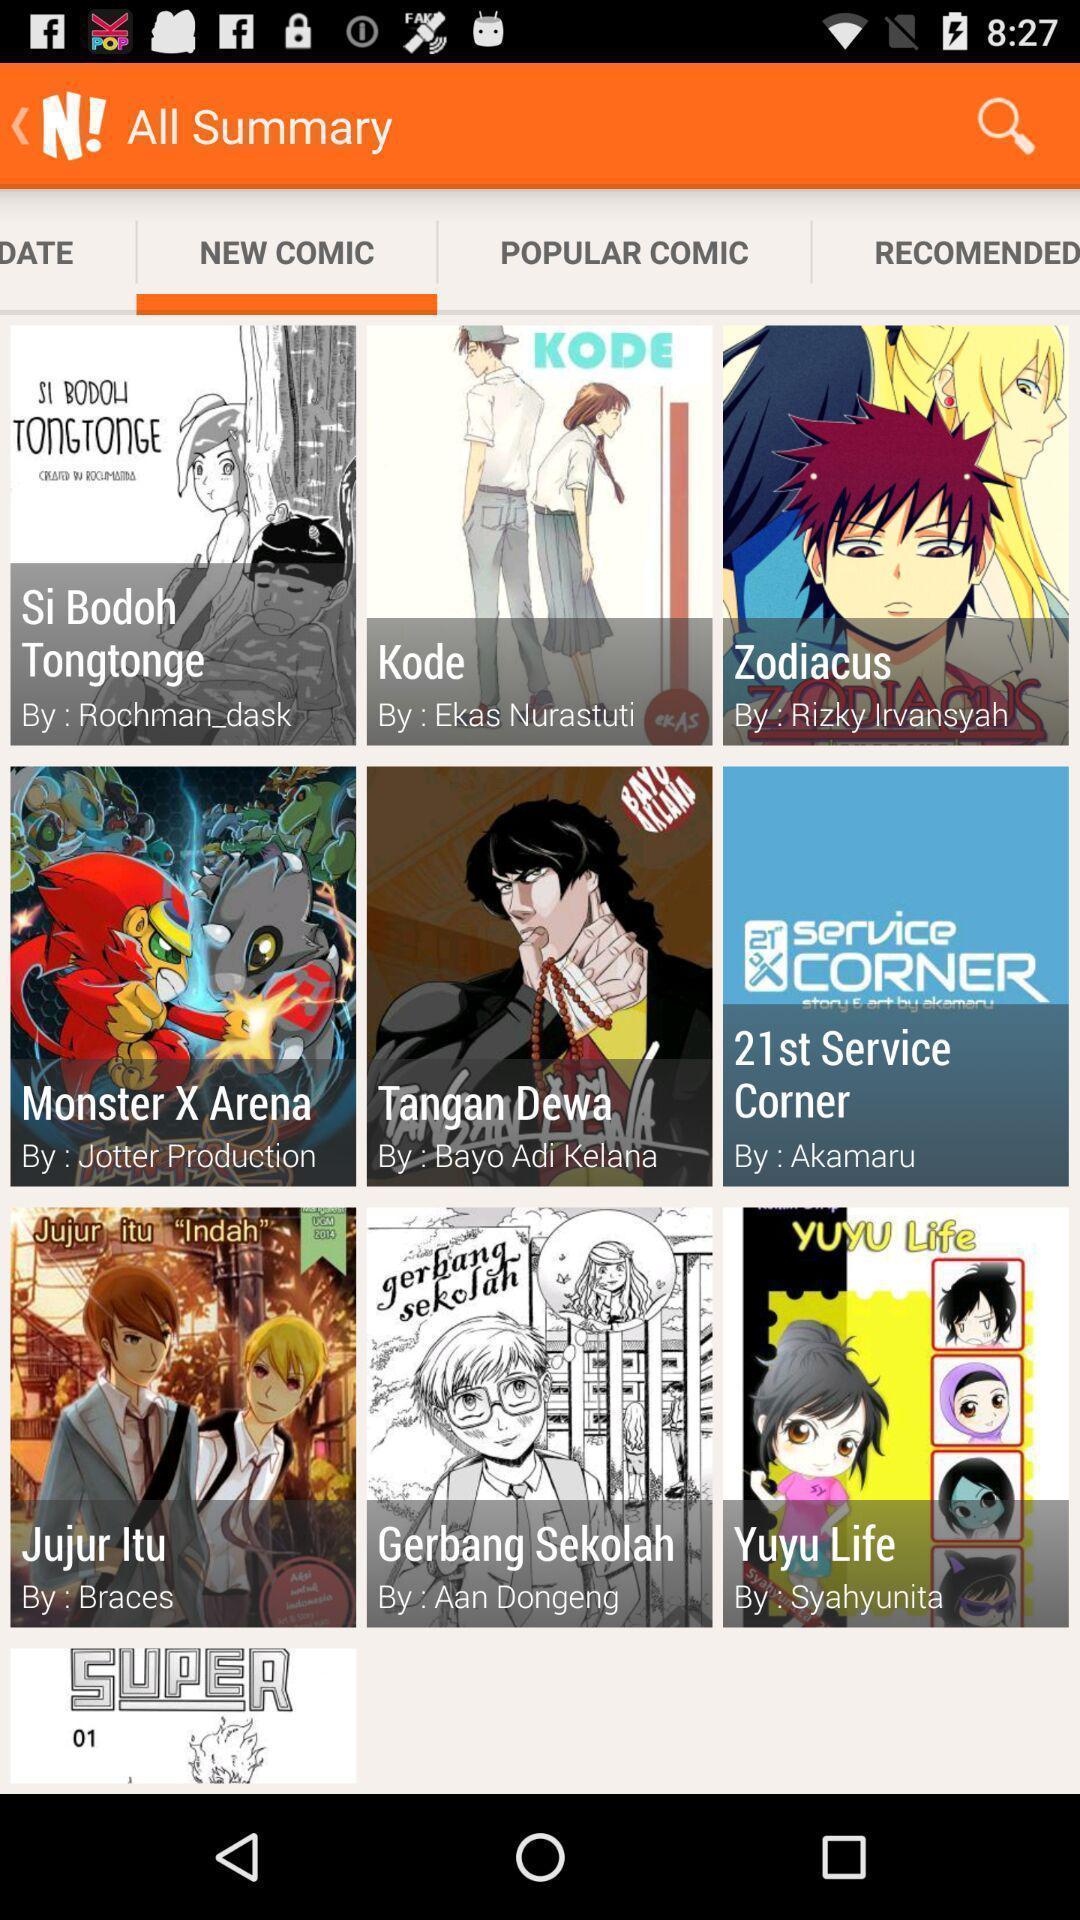What can you discern from this picture? Page displaying various articles. 